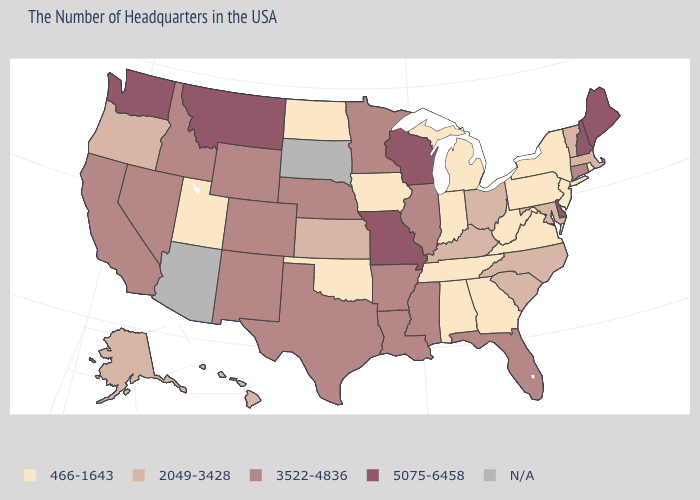Which states have the highest value in the USA?
Keep it brief. Maine, New Hampshire, Delaware, Wisconsin, Missouri, Montana, Washington. Among the states that border Ohio , which have the lowest value?
Be succinct. Pennsylvania, West Virginia, Michigan, Indiana. What is the value of New Hampshire?
Give a very brief answer. 5075-6458. What is the value of Ohio?
Quick response, please. 2049-3428. What is the value of Montana?
Concise answer only. 5075-6458. Name the states that have a value in the range 3522-4836?
Write a very short answer. Connecticut, Florida, Illinois, Mississippi, Louisiana, Arkansas, Minnesota, Nebraska, Texas, Wyoming, Colorado, New Mexico, Idaho, Nevada, California. What is the highest value in states that border Delaware?
Answer briefly. 2049-3428. What is the value of Maryland?
Write a very short answer. 2049-3428. Name the states that have a value in the range 2049-3428?
Short answer required. Massachusetts, Vermont, Maryland, North Carolina, South Carolina, Ohio, Kentucky, Kansas, Oregon, Alaska, Hawaii. Which states have the highest value in the USA?
Keep it brief. Maine, New Hampshire, Delaware, Wisconsin, Missouri, Montana, Washington. Among the states that border Maryland , does West Virginia have the highest value?
Keep it brief. No. Which states have the highest value in the USA?
Write a very short answer. Maine, New Hampshire, Delaware, Wisconsin, Missouri, Montana, Washington. Name the states that have a value in the range 2049-3428?
Short answer required. Massachusetts, Vermont, Maryland, North Carolina, South Carolina, Ohio, Kentucky, Kansas, Oregon, Alaska, Hawaii. Does New Jersey have the highest value in the Northeast?
Give a very brief answer. No. What is the value of Oklahoma?
Keep it brief. 466-1643. 